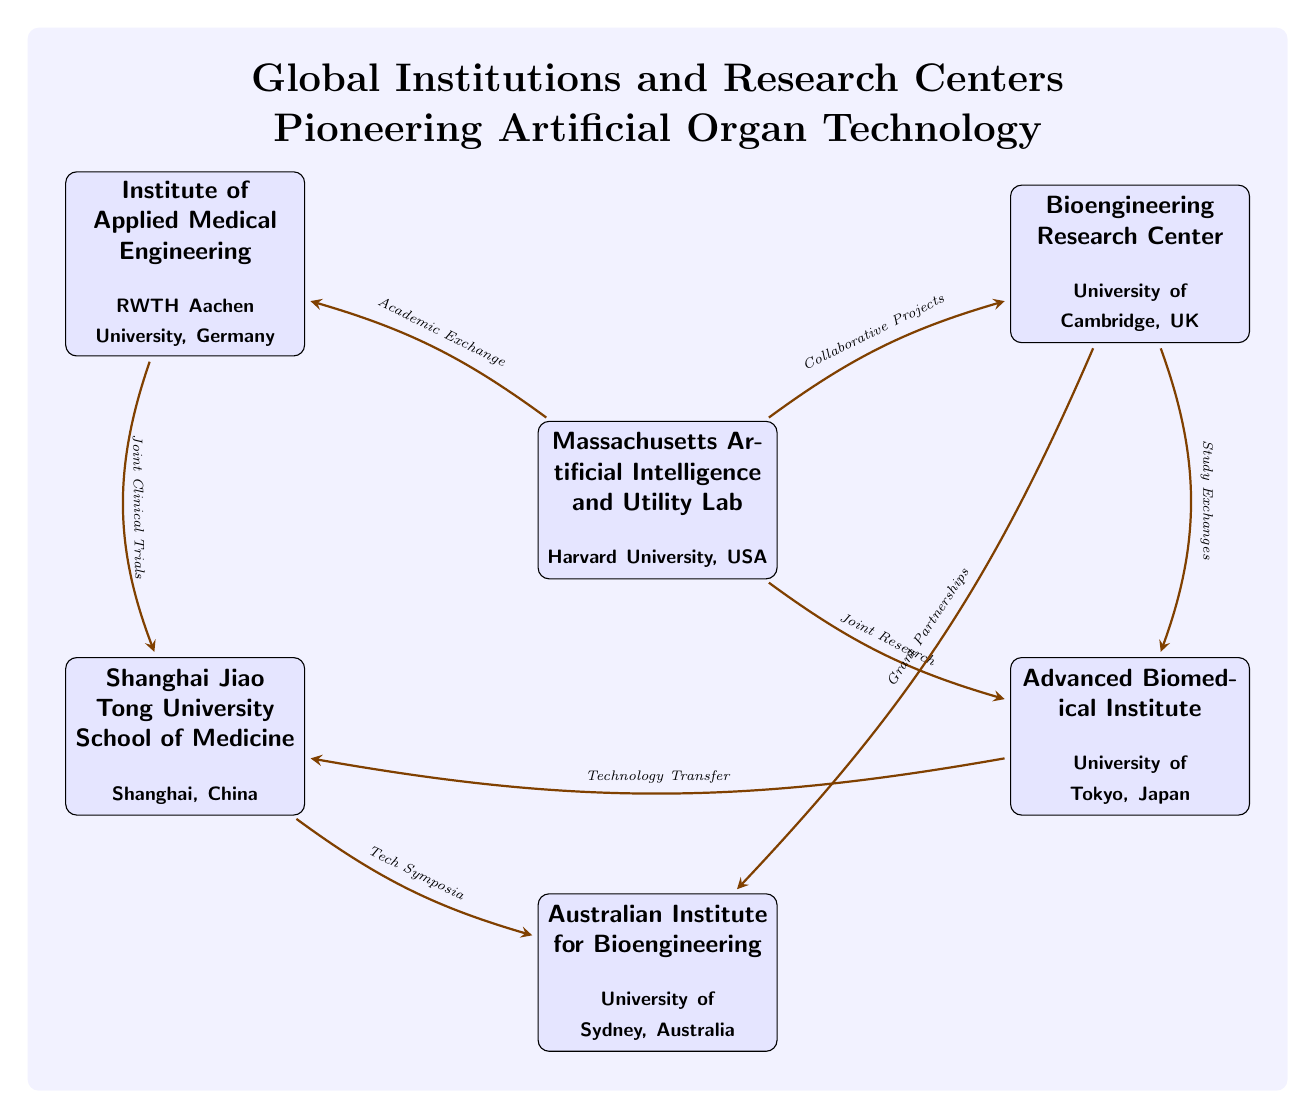What institutions are represented in the diagram? The diagram includes six institutions: Massachusetts Artificial Intelligence and Utility Lab, Bioengineering Research Center, Advanced Biomedical Institute, Institute of Applied Medical Engineering, Shanghai Jiao Tong University School of Medicine, and Australian Institute for Bioengineering.
Answer: Six institutions Which institution is located in Australia? The Australian Institute for Bioengineering is identified as being located at the University of Sydney, Australia, according to the diagram.
Answer: Australian Institute for Bioengineering What type of relationships exist between Harvard and Cambridge? The diagram shows a connection labeled "Collaborative Projects" between Harvard and Cambridge, indicating one of the types of collaborations between these two institutions.
Answer: Collaborative Projects How many total connections are illustrated in the diagram? There are eight arrows connecting various institutions, each representing a type of relationship, therefore indicating that there are a total of eight connections in the diagram.
Answer: Eight connections Which institution has a connection with Shanghai and what is the nature of this connection? The diagram shows that the Advanced Biomedical Institute in Tokyo has a connection with Shanghai, labeled "Technology Transfer." This describes the relationship being depicted.
Answer: Technology Transfer Which institution partnered with Sydney for a specific purpose? The diagram specifies that the Bioengineering Research Center from Cambridge has a partnership labeled "Grant Partnerships" with the Australian Institute for Bioengineering in Sydney.
Answer: Grant Partnerships What is the overall purpose of these institutions depicted in the diagram? The institutions in the diagram are collectively represented as pioneers in artificial organ technology, indicating their shared focus in this field of research and innovation.
Answer: Pioneering artificial organ technology Which institution initiates the most collaborations according to the diagram? Harvard, as the central node in the diagram, showcases multiple connections, thus indicating it initiates the most collaborations including connections with Cambridge, Tokyo, and Aachen.
Answer: Harvard 